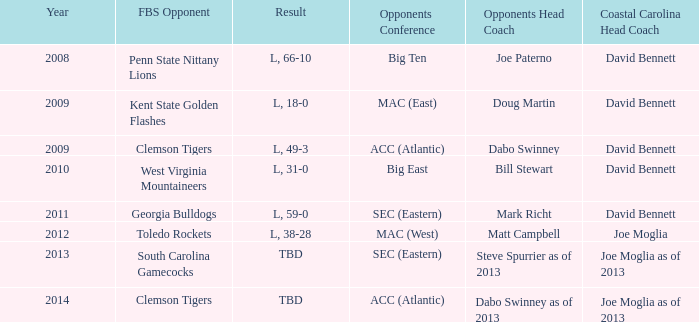Who served as the coastal carolina head coach in 2013? Joe Moglia as of 2013. Parse the full table. {'header': ['Year', 'FBS Opponent', 'Result', 'Opponents Conference', 'Opponents Head Coach', 'Coastal Carolina Head Coach'], 'rows': [['2008', 'Penn State Nittany Lions', 'L, 66-10', 'Big Ten', 'Joe Paterno', 'David Bennett'], ['2009', 'Kent State Golden Flashes', 'L, 18-0', 'MAC (East)', 'Doug Martin', 'David Bennett'], ['2009', 'Clemson Tigers', 'L, 49-3', 'ACC (Atlantic)', 'Dabo Swinney', 'David Bennett'], ['2010', 'West Virginia Mountaineers', 'L, 31-0', 'Big East', 'Bill Stewart', 'David Bennett'], ['2011', 'Georgia Bulldogs', 'L, 59-0', 'SEC (Eastern)', 'Mark Richt', 'David Bennett'], ['2012', 'Toledo Rockets', 'L, 38-28', 'MAC (West)', 'Matt Campbell', 'Joe Moglia'], ['2013', 'South Carolina Gamecocks', 'TBD', 'SEC (Eastern)', 'Steve Spurrier as of 2013', 'Joe Moglia as of 2013'], ['2014', 'Clemson Tigers', 'TBD', 'ACC (Atlantic)', 'Dabo Swinney as of 2013', 'Joe Moglia as of 2013']]} 